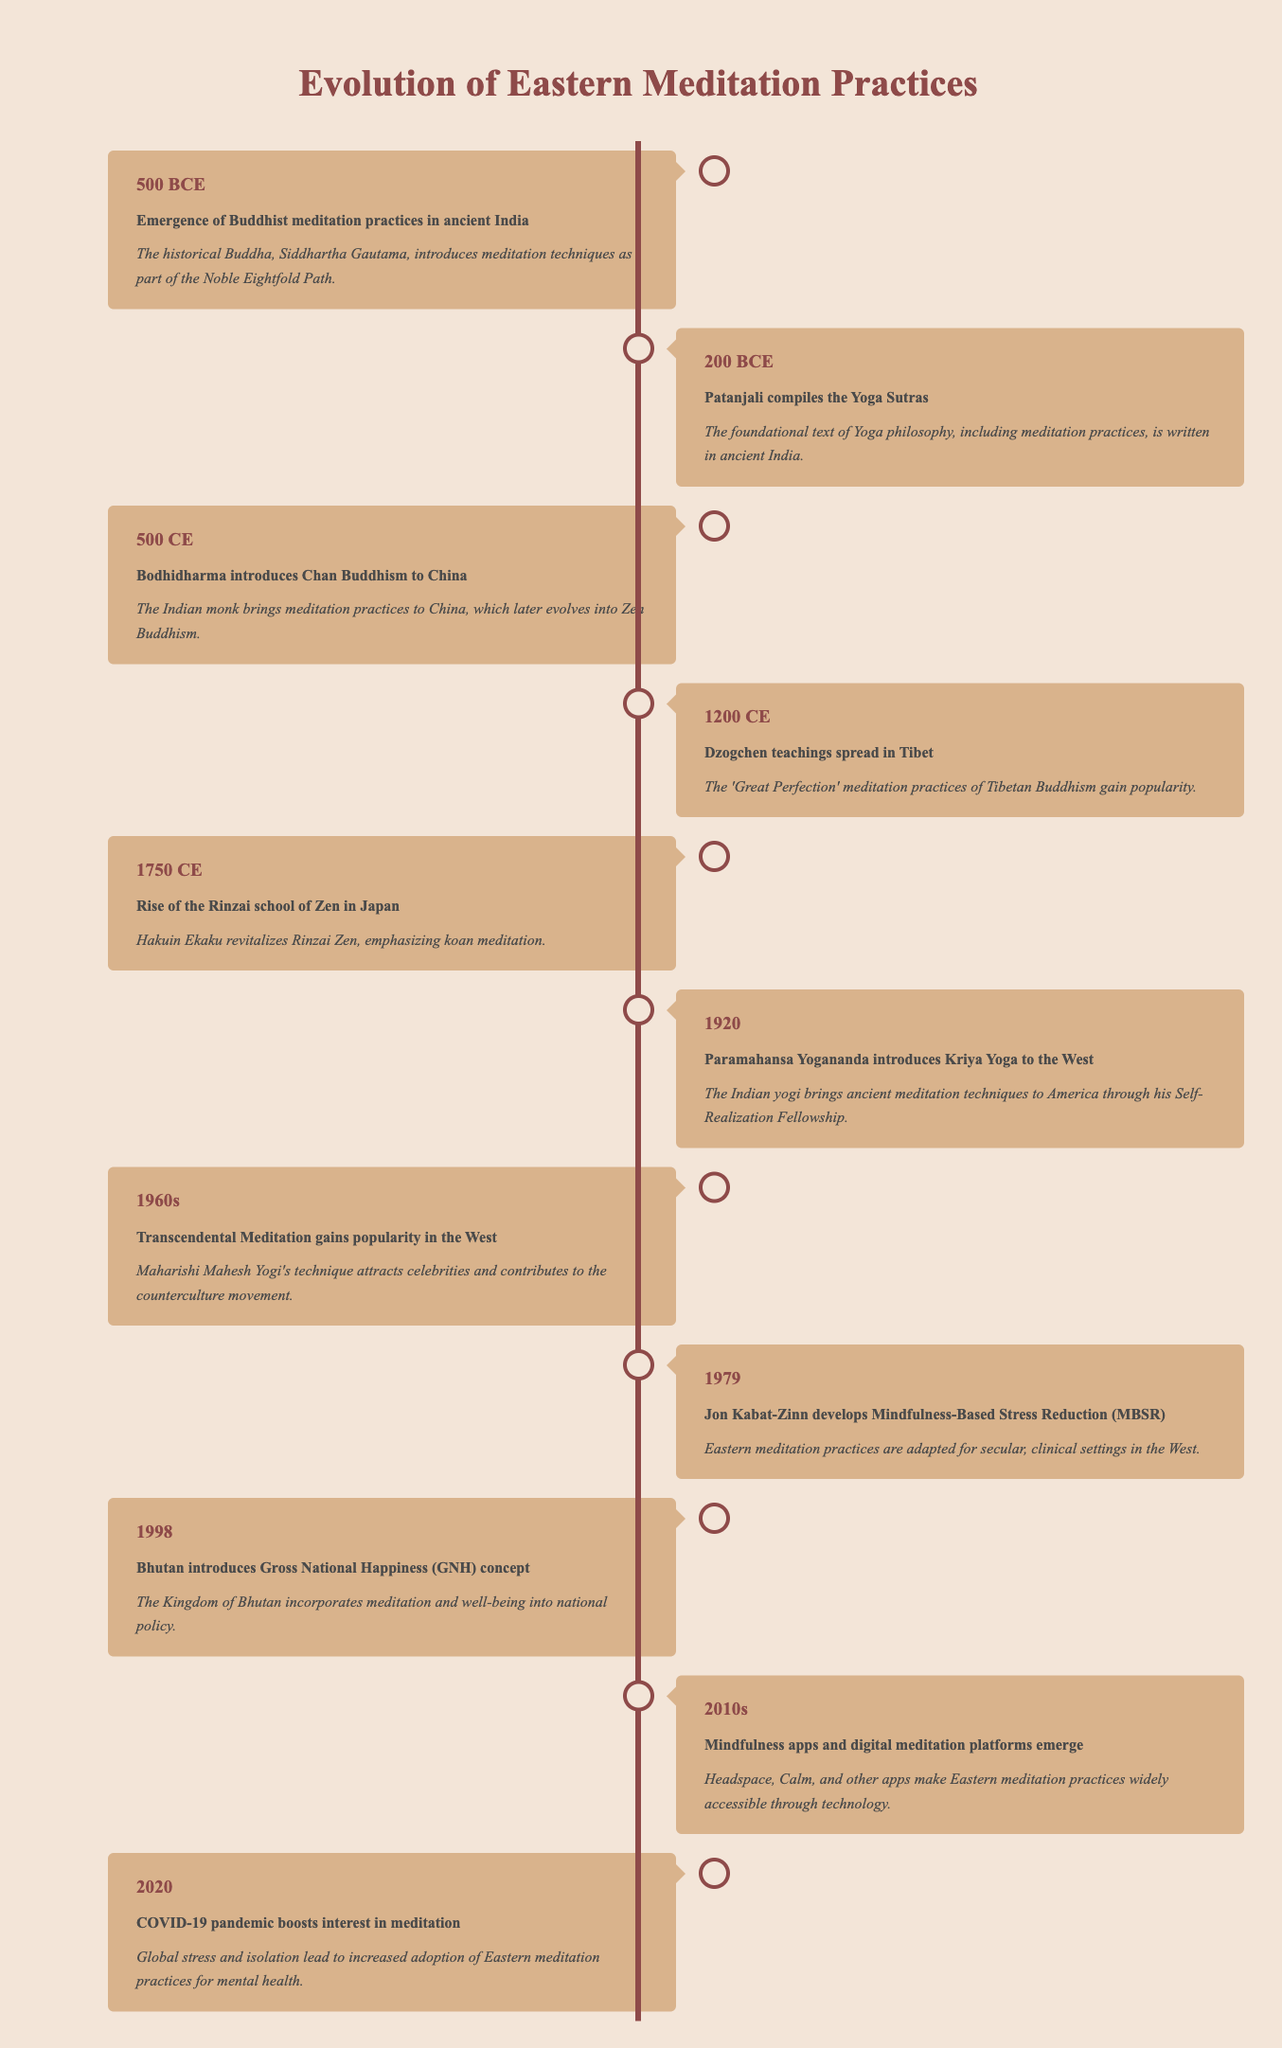What year did the historical Buddha introduce meditation practices? The table indicates that the emergence of Buddhist meditation practices was recorded in the year 500 BCE, when Siddhartha Gautama, the historical Buddha, introduced them.
Answer: 500 BCE Which text did Patanjali compile, and when? According to the table, Patanjali compiled the Yoga Sutras in 200 BCE, which is noted as the foundational text of Yoga philosophy.
Answer: Yoga Sutras in 200 BCE How many years are there between the introduction of Chan Buddhism to China and the rise of the Rinzai school of Zen in Japan? The introduction of Chan Buddhism occurred in 500 CE, and the rise of the Rinzai school took place in 1750 CE. To find the difference, subtract 500 from 1750, resulting in 1250 years.
Answer: 1250 years Did Bhutan introduce the Gross National Happiness concept before or after the 1960s? The table shows that Bhutan introduced the GNH concept in 1998, which is after the 1960s. By examining the timeline, we can confirm this ordering.
Answer: After What major shift in meditation popularity occurred during the 1960s? The table notes that during the 1960s, Transcendental Meditation gained popularity in the West, particularly due to its appeal among celebrities and its contribution to the counterculture movement.
Answer: Transcendental Meditation gained popularity What was the significance of the year 1979 in relation to Eastern meditation practices? In 1979, Jon Kabat-Zinn developed the Mindfulness-Based Stress Reduction program, adapting Eastern meditation practices for secular settings in the West. This marked a significant step in integrating these practices into mainstream health and wellness.
Answer: Jon Kabat-Zinn developed MBSR How many events related to the evolution of Eastern meditation practices occurred before the 20th century? The timeline in the table shows there are six events before the year 1900: 500 BCE, 200 BCE, 500 CE, 1200 CE, 1750 CE, and 1920 (the last of which is in the 20th century). Adding these gives a total of 6 events.
Answer: 6 events What two major developments in meditation practices happened in Bhutan and the 2010s? The table specifies that in 1998, Bhutan introduced the Gross National Happiness concept blending meditation into national policy, and in the 2010s, mindfulness apps emerged, making these practices widely accessible through technology. Both represent significant advancements in integrating meditation into everyday life.
Answer: GNH in 1998 and mindfulness apps in the 2010s 